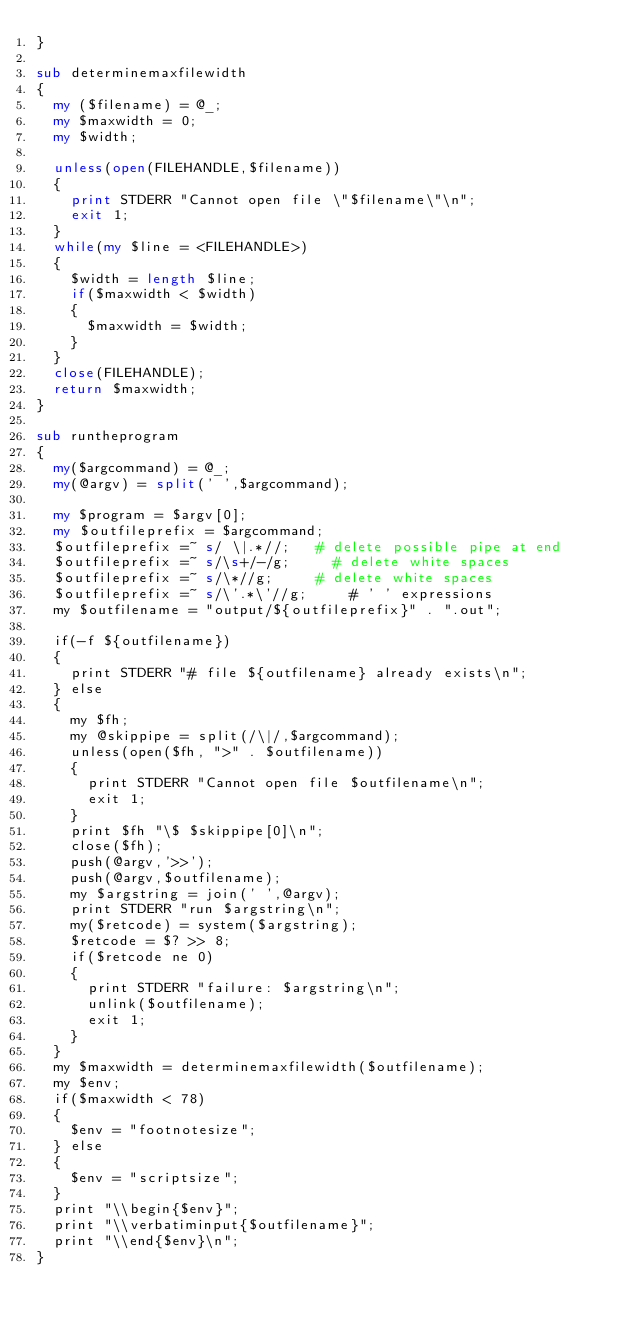Convert code to text. <code><loc_0><loc_0><loc_500><loc_500><_Perl_>}

sub determinemaxfilewidth
{
  my ($filename) = @_;
  my $maxwidth = 0;
  my $width;

  unless(open(FILEHANDLE,$filename))
  {
    print STDERR "Cannot open file \"$filename\"\n";
    exit 1;
  }
  while(my $line = <FILEHANDLE>)
  {
    $width = length $line;
    if($maxwidth < $width)
    {
      $maxwidth = $width;
    }
  }
  close(FILEHANDLE);
  return $maxwidth;
}

sub runtheprogram
{
  my($argcommand) = @_;
  my(@argv) = split(' ',$argcommand);

  my $program = $argv[0];
  my $outfileprefix = $argcommand;
  $outfileprefix =~ s/ \|.*//;   # delete possible pipe at end
  $outfileprefix =~ s/\s+/-/g;     # delete white spaces
  $outfileprefix =~ s/\*//g;     # delete white spaces
  $outfileprefix =~ s/\'.*\'//g;     # ' ' expressions
  my $outfilename = "output/${outfileprefix}" . ".out";

  if(-f ${outfilename})
  {
    print STDERR "# file ${outfilename} already exists\n";
  } else
  {
    my $fh;
    my @skippipe = split(/\|/,$argcommand);
    unless(open($fh, ">" . $outfilename))
    {
      print STDERR "Cannot open file $outfilename\n";
      exit 1;
    }
    print $fh "\$ $skippipe[0]\n";
    close($fh);
    push(@argv,'>>');
    push(@argv,$outfilename);
    my $argstring = join(' ',@argv);
    print STDERR "run $argstring\n";
    my($retcode) = system($argstring);
    $retcode = $? >> 8;
    if($retcode ne 0)
    {
      print STDERR "failure: $argstring\n";
      unlink($outfilename);
      exit 1;
    }
  }
  my $maxwidth = determinemaxfilewidth($outfilename);
  my $env;
  if($maxwidth < 78)
  {
    $env = "footnotesize";
  } else
  {
    $env = "scriptsize";
  }
  print "\\begin{$env}";
  print "\\verbatiminput{$outfilename}";
  print "\\end{$env}\n";
}
</code> 